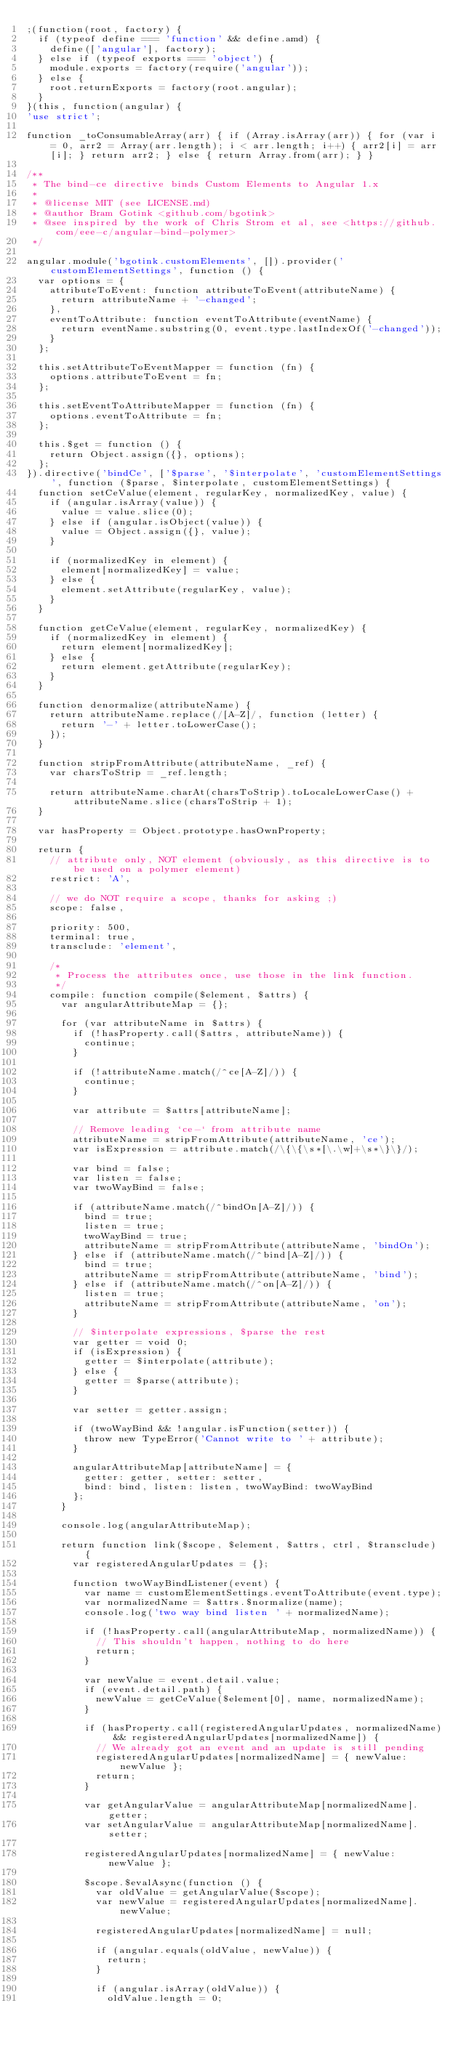Convert code to text. <code><loc_0><loc_0><loc_500><loc_500><_JavaScript_>;(function(root, factory) {
  if (typeof define === 'function' && define.amd) {
    define(['angular'], factory);
  } else if (typeof exports === 'object') {
    module.exports = factory(require('angular'));
  } else {
    root.returnExports = factory(root.angular);
  }
}(this, function(angular) {
'use strict';

function _toConsumableArray(arr) { if (Array.isArray(arr)) { for (var i = 0, arr2 = Array(arr.length); i < arr.length; i++) { arr2[i] = arr[i]; } return arr2; } else { return Array.from(arr); } }

/**
 * The bind-ce directive binds Custom Elements to Angular 1.x
 *
 * @license MIT (see LICENSE.md)
 * @author Bram Gotink <github.com/bgotink>
 * @see inspired by the work of Chris Strom et al, see <https://github.com/eee-c/angular-bind-polymer>
 */

angular.module('bgotink.customElements', []).provider('customElementSettings', function () {
  var options = {
    attributeToEvent: function attributeToEvent(attributeName) {
      return attributeName + '-changed';
    },
    eventToAttribute: function eventToAttribute(eventName) {
      return eventName.substring(0, event.type.lastIndexOf('-changed'));
    }
  };

  this.setAttributeToEventMapper = function (fn) {
    options.attributeToEvent = fn;
  };

  this.setEventToAttributeMapper = function (fn) {
    options.eventToAttribute = fn;
  };

  this.$get = function () {
    return Object.assign({}, options);
  };
}).directive('bindCe', ['$parse', '$interpolate', 'customElementSettings', function ($parse, $interpolate, customElementSettings) {
  function setCeValue(element, regularKey, normalizedKey, value) {
    if (angular.isArray(value)) {
      value = value.slice(0);
    } else if (angular.isObject(value)) {
      value = Object.assign({}, value);
    }

    if (normalizedKey in element) {
      element[normalizedKey] = value;
    } else {
      element.setAttribute(regularKey, value);
    }
  }

  function getCeValue(element, regularKey, normalizedKey) {
    if (normalizedKey in element) {
      return element[normalizedKey];
    } else {
      return element.getAttribute(regularKey);
    }
  }

  function denormalize(attributeName) {
    return attributeName.replace(/[A-Z]/, function (letter) {
      return '-' + letter.toLowerCase();
    });
  }

  function stripFromAttribute(attributeName, _ref) {
    var charsToStrip = _ref.length;

    return attributeName.charAt(charsToStrip).toLocaleLowerCase() + attributeName.slice(charsToStrip + 1);
  }

  var hasProperty = Object.prototype.hasOwnProperty;

  return {
    // attribute only, NOT element (obviously, as this directive is to be used on a polymer element)
    restrict: 'A',

    // we do NOT require a scope, thanks for asking ;)
    scope: false,

    priority: 500,
    terminal: true,
    transclude: 'element',

    /*
     * Process the attributes once, use those in the link function.
     */
    compile: function compile($element, $attrs) {
      var angularAttributeMap = {};

      for (var attributeName in $attrs) {
        if (!hasProperty.call($attrs, attributeName)) {
          continue;
        }

        if (!attributeName.match(/^ce[A-Z]/)) {
          continue;
        }

        var attribute = $attrs[attributeName];

        // Remove leading `ce-` from attribute name
        attributeName = stripFromAttribute(attributeName, 'ce');
        var isExpression = attribute.match(/\{\{\s*[\.\w]+\s*\}\}/);

        var bind = false;
        var listen = false;
        var twoWayBind = false;

        if (attributeName.match(/^bindOn[A-Z]/)) {
          bind = true;
          listen = true;
          twoWayBind = true;
          attributeName = stripFromAttribute(attributeName, 'bindOn');
        } else if (attributeName.match(/^bind[A-Z]/)) {
          bind = true;
          attributeName = stripFromAttribute(attributeName, 'bind');
        } else if (attributeName.match(/^on[A-Z]/)) {
          listen = true;
          attributeName = stripFromAttribute(attributeName, 'on');
        }

        // $interpolate expressions, $parse the rest
        var getter = void 0;
        if (isExpression) {
          getter = $interpolate(attribute);
        } else {
          getter = $parse(attribute);
        }

        var setter = getter.assign;

        if (twoWayBind && !angular.isFunction(setter)) {
          throw new TypeError('Cannot write to ' + attribute);
        }

        angularAttributeMap[attributeName] = {
          getter: getter, setter: setter,
          bind: bind, listen: listen, twoWayBind: twoWayBind
        };
      }

      console.log(angularAttributeMap);

      return function link($scope, $element, $attrs, ctrl, $transclude) {
        var registeredAngularUpdates = {};

        function twoWayBindListener(event) {
          var name = customElementSettings.eventToAttribute(event.type);
          var normalizedName = $attrs.$normalize(name);
          console.log('two way bind listen ' + normalizedName);

          if (!hasProperty.call(angularAttributeMap, normalizedName)) {
            // This shouldn't happen, nothing to do here
            return;
          }

          var newValue = event.detail.value;
          if (event.detail.path) {
            newValue = getCeValue($element[0], name, normalizedName);
          }

          if (hasProperty.call(registeredAngularUpdates, normalizedName) && registeredAngularUpdates[normalizedName]) {
            // We already got an event and an update is still pending
            registeredAngularUpdates[normalizedName] = { newValue: newValue };
            return;
          }

          var getAngularValue = angularAttributeMap[normalizedName].getter;
          var setAngularValue = angularAttributeMap[normalizedName].setter;

          registeredAngularUpdates[normalizedName] = { newValue: newValue };

          $scope.$evalAsync(function () {
            var oldValue = getAngularValue($scope);
            var newValue = registeredAngularUpdates[normalizedName].newValue;

            registeredAngularUpdates[normalizedName] = null;

            if (angular.equals(oldValue, newValue)) {
              return;
            }

            if (angular.isArray(oldValue)) {
              oldValue.length = 0;</code> 